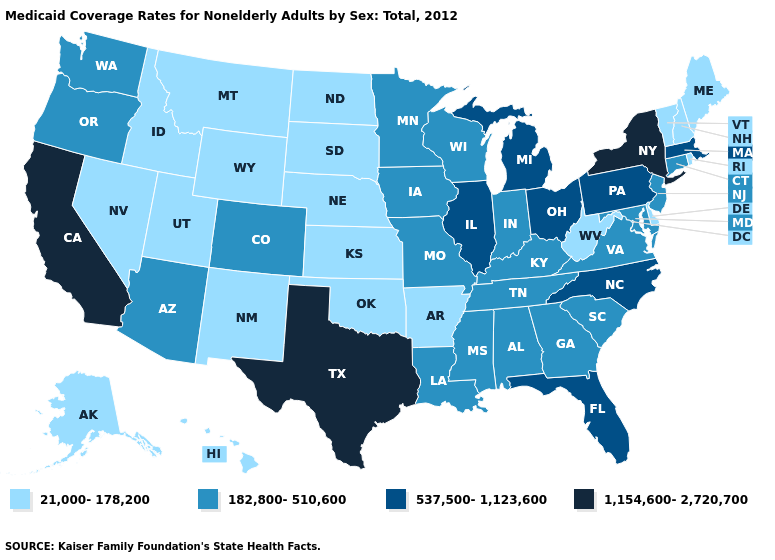Does South Carolina have the lowest value in the South?
Be succinct. No. Does the map have missing data?
Keep it brief. No. Does Iowa have the lowest value in the USA?
Write a very short answer. No. Name the states that have a value in the range 21,000-178,200?
Keep it brief. Alaska, Arkansas, Delaware, Hawaii, Idaho, Kansas, Maine, Montana, Nebraska, Nevada, New Hampshire, New Mexico, North Dakota, Oklahoma, Rhode Island, South Dakota, Utah, Vermont, West Virginia, Wyoming. What is the highest value in states that border Oregon?
Short answer required. 1,154,600-2,720,700. Does Ohio have the highest value in the MidWest?
Quick response, please. Yes. What is the lowest value in the USA?
Be succinct. 21,000-178,200. Among the states that border West Virginia , which have the lowest value?
Answer briefly. Kentucky, Maryland, Virginia. Does New York have the highest value in the USA?
Concise answer only. Yes. Does Nebraska have the highest value in the MidWest?
Give a very brief answer. No. What is the value of Kentucky?
Answer briefly. 182,800-510,600. Does the first symbol in the legend represent the smallest category?
Keep it brief. Yes. Which states have the lowest value in the MidWest?
Answer briefly. Kansas, Nebraska, North Dakota, South Dakota. Does Indiana have the lowest value in the MidWest?
Concise answer only. No. Name the states that have a value in the range 21,000-178,200?
Answer briefly. Alaska, Arkansas, Delaware, Hawaii, Idaho, Kansas, Maine, Montana, Nebraska, Nevada, New Hampshire, New Mexico, North Dakota, Oklahoma, Rhode Island, South Dakota, Utah, Vermont, West Virginia, Wyoming. 